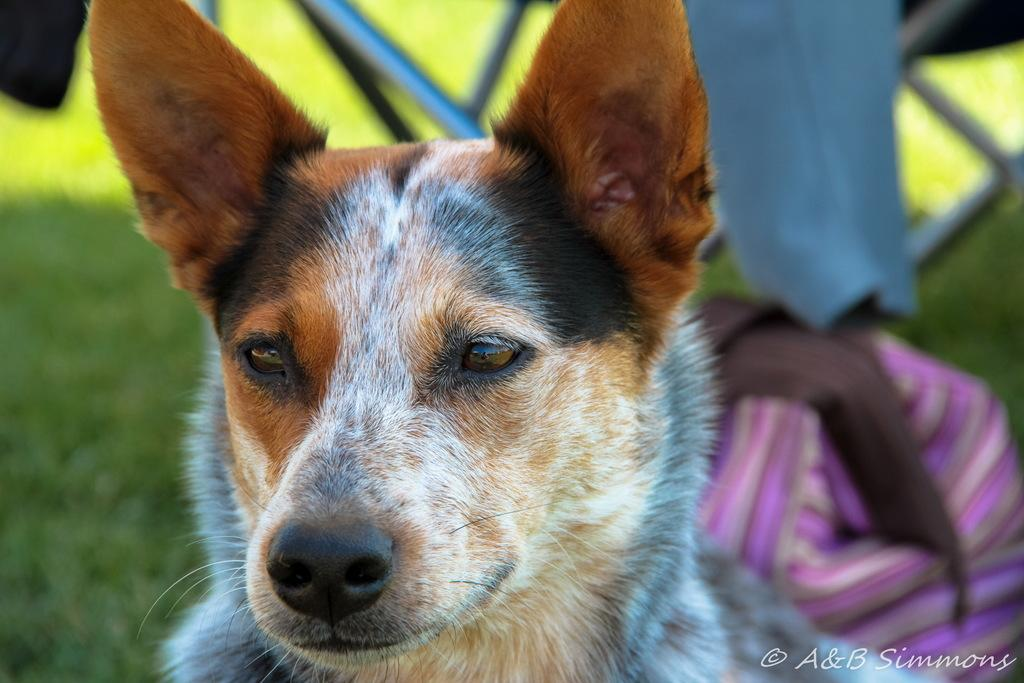What type of animal is in the image? There is a dog in the image. What color is the dog? The dog is brown in color. Can you describe the background of the image? The background of the image is blurred. Is the ghost visible in the image? There is no ghost present in the image. What is the dog's temper like in the image? The dog's temper cannot be determined from the image, as it is a still photograph. 